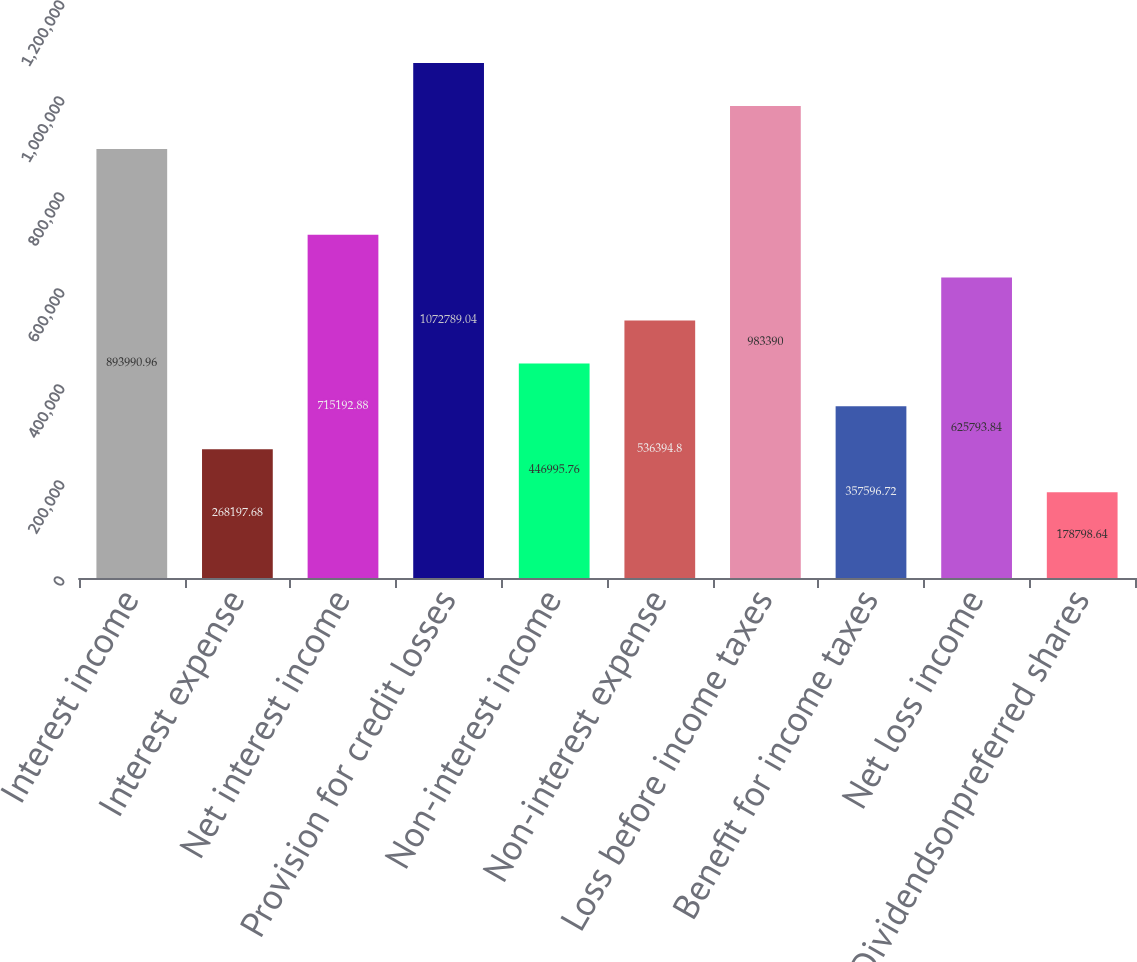Convert chart. <chart><loc_0><loc_0><loc_500><loc_500><bar_chart><fcel>Interest income<fcel>Interest expense<fcel>Net interest income<fcel>Provision for credit losses<fcel>Non-interest income<fcel>Non-interest expense<fcel>Loss before income taxes<fcel>Benefit for income taxes<fcel>Net loss income<fcel>Dividendsonpreferred shares<nl><fcel>893991<fcel>268198<fcel>715193<fcel>1.07279e+06<fcel>446996<fcel>536395<fcel>983390<fcel>357597<fcel>625794<fcel>178799<nl></chart> 